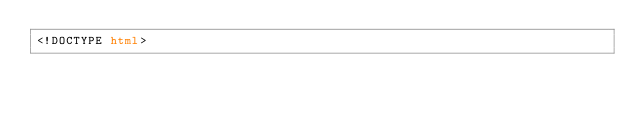Convert code to text. <code><loc_0><loc_0><loc_500><loc_500><_HTML_><!DOCTYPE html></code> 